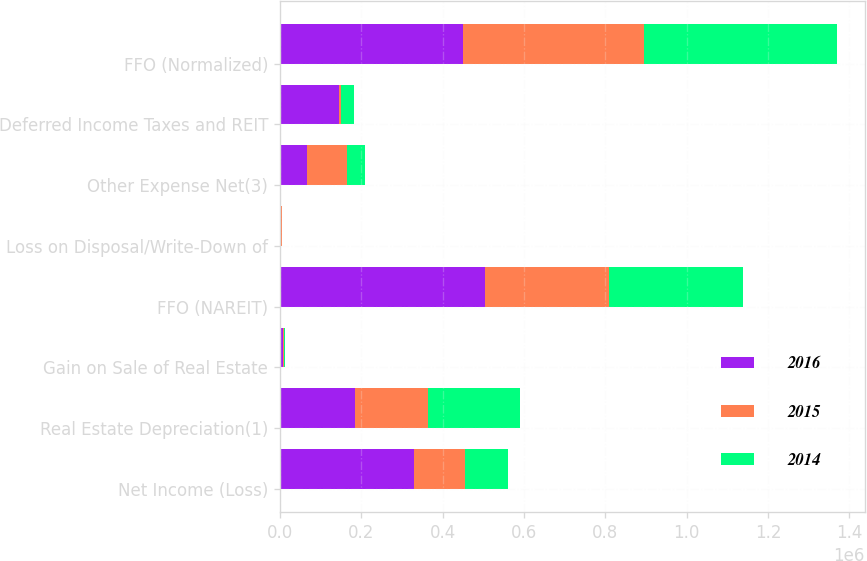Convert chart to OTSL. <chart><loc_0><loc_0><loc_500><loc_500><stacked_bar_chart><ecel><fcel>Net Income (Loss)<fcel>Real Estate Depreciation(1)<fcel>Gain on Sale of Real Estate<fcel>FFO (NAREIT)<fcel>Loss on Disposal/Write-Down of<fcel>Other Expense Net(3)<fcel>Deferred Income Taxes and REIT<fcel>FFO (Normalized)<nl><fcel>2016<fcel>328746<fcel>184170<fcel>8307<fcel>504609<fcel>1065<fcel>65187<fcel>144154<fcel>449228<nl><fcel>2015<fcel>125203<fcel>178800<fcel>850<fcel>303153<fcel>3000<fcel>98590<fcel>5513<fcel>446244<nl><fcel>2014<fcel>107233<fcel>226258<fcel>2180<fcel>331311<fcel>1412<fcel>44300<fcel>31944<fcel>473670<nl></chart> 